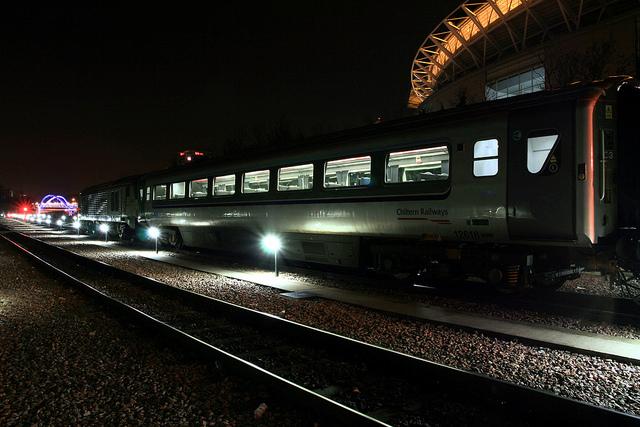Is the train in motion?
Keep it brief. Yes. Is it daytime?
Write a very short answer. No. Are the lights on inside the train?
Give a very brief answer. Yes. 